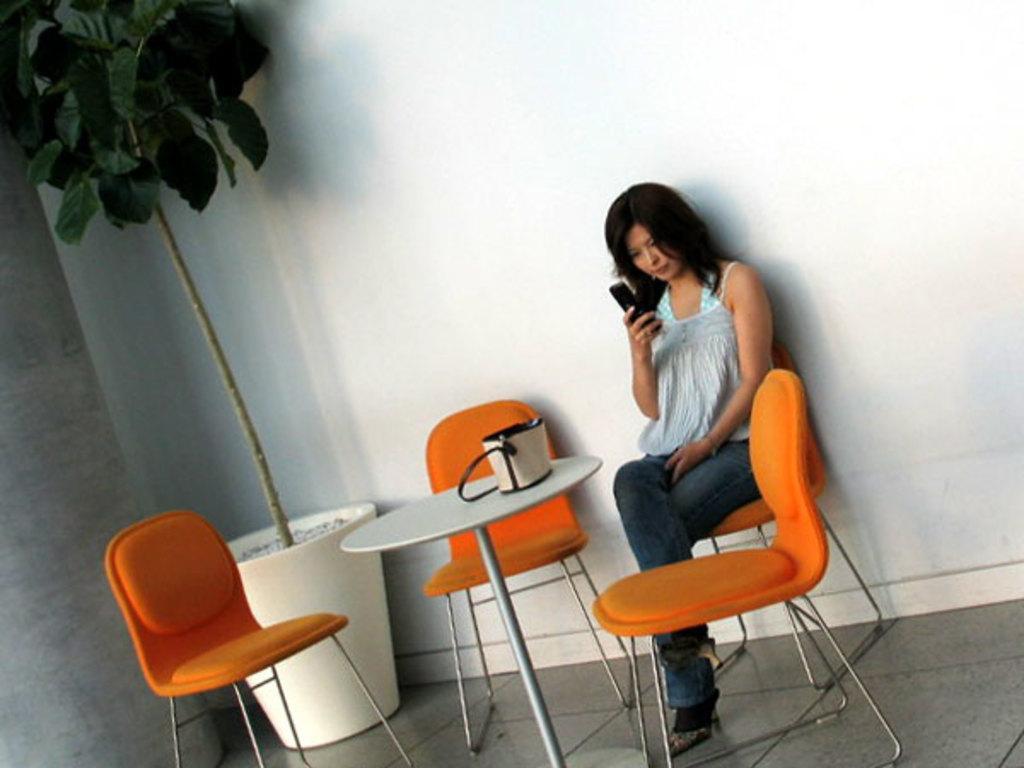Could you give a brief overview of what you see in this image? In the image there is a woman sat on a chair in front of her there is table with handbag on it and on the left side corner there is a tree. 